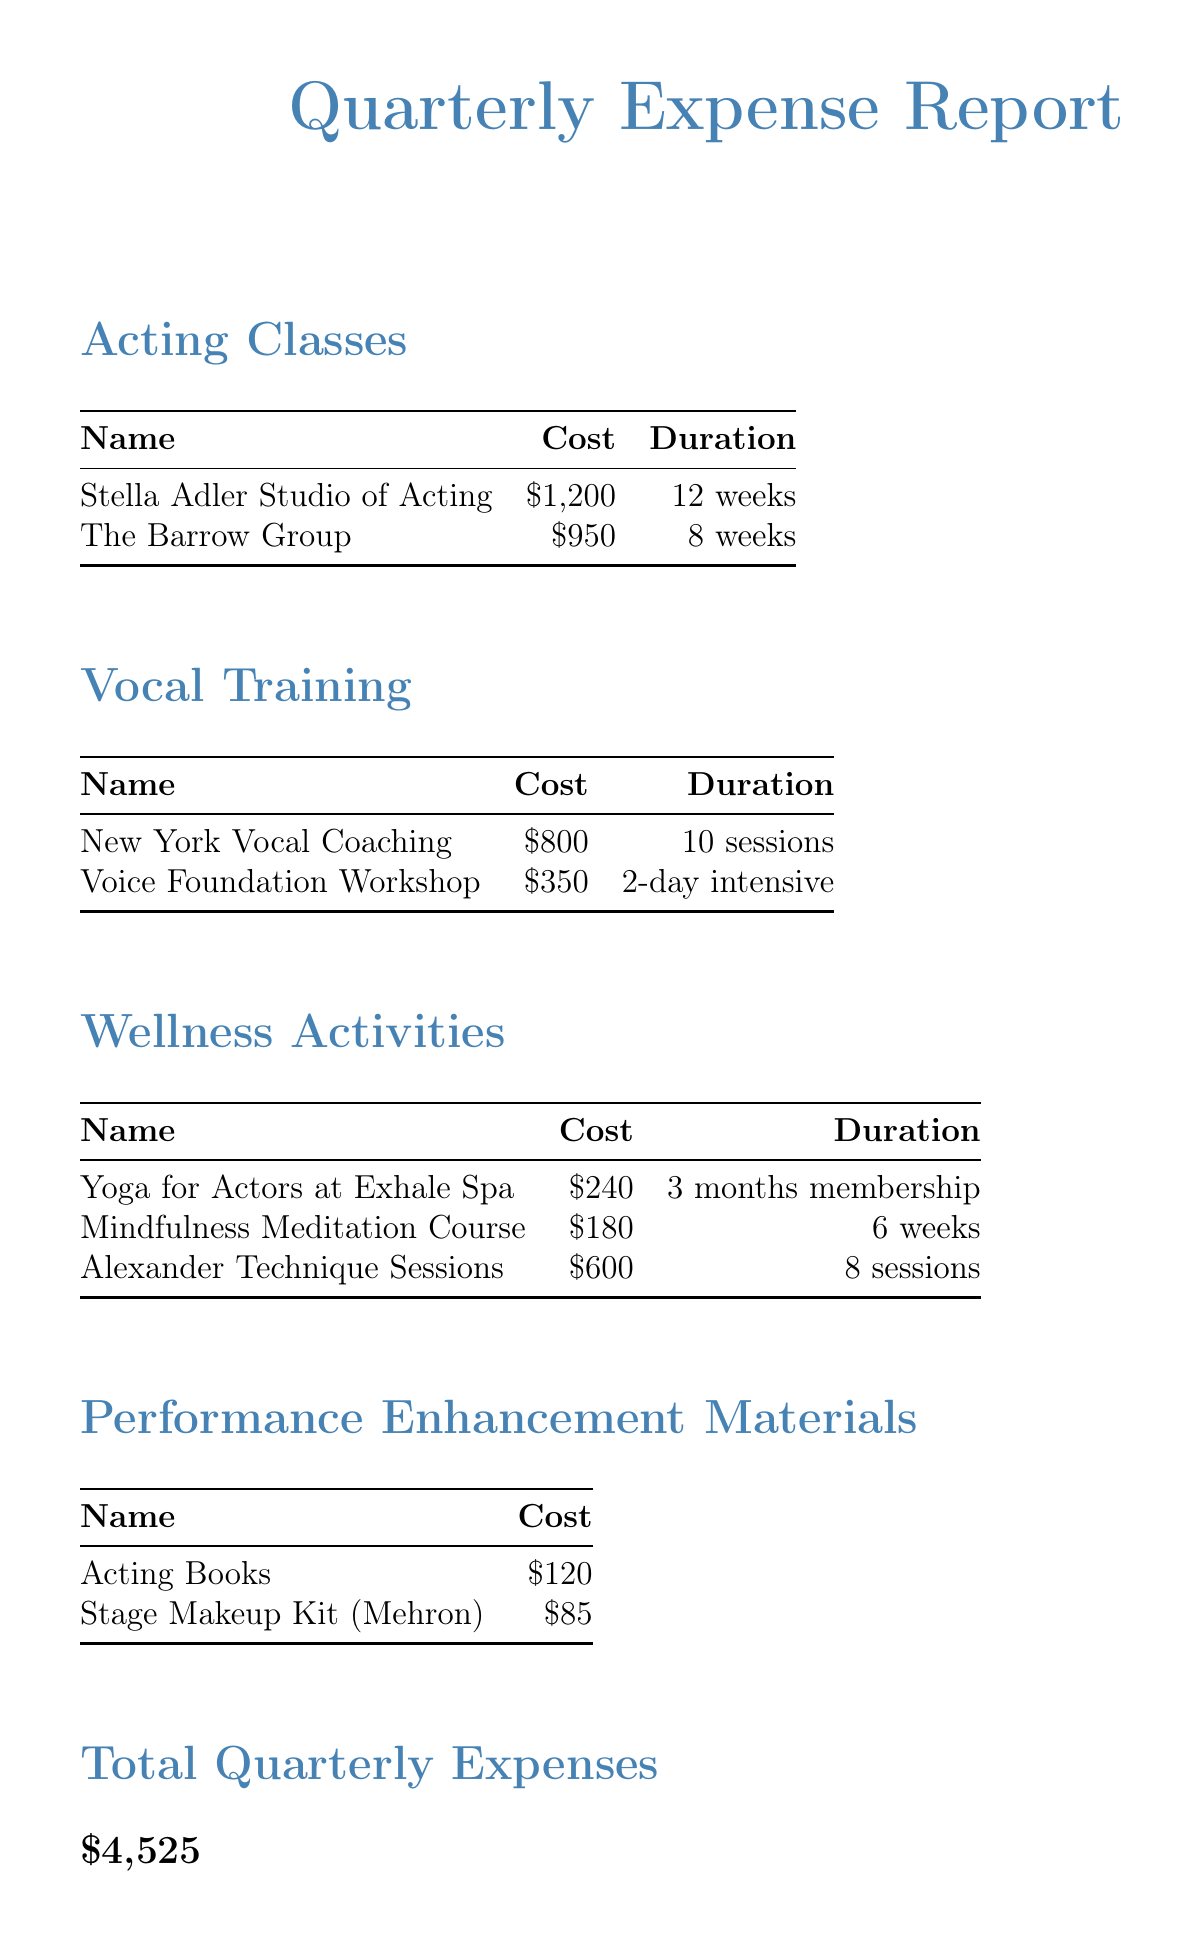what is the total quarterly expense? The total quarterly expense is provided as the final amount in the document under "Total Quarterly Expenses."
Answer: $4,525 how many weeks is the duration of the Stella Adler Studio of Acting? The duration of the Stella Adler Studio of Acting is mentioned in the table of acting classes.
Answer: 12 weeks what is the cost of the Voice Foundation Workshop? The Voice Foundation Workshop's cost is listed in the vocal training section of the document.
Answer: $350 how many sessions does New York Vocal Coaching provide? The duration of New York Vocal Coaching is indicated in the vocal training section stating the number of sessions.
Answer: 10 sessions which wellness activity costs $240? The wellness activity costing $240 is specified in the wellness activities section of the document.
Answer: Yoga for Actors at Exhale Spa what type of enhancement materials are included in the expenses? The document lists types of materials under a section dedicated to performance enhancement materials.
Answer: Acting Books, Stage Makeup Kit why is holistic wellness emphasized in the notes? The notes section states the purpose of investing in wellness activities, highlighting a significant focus on sustainability in the actor's career.
Answer: long-term career sustainability who is the brand of the Stage Makeup Kit? The brand of the Stage Makeup Kit is given in the list of performance enhancement materials, indicating the specific brand used.
Answer: Mehron how many weeks is the duration of the Mindfulness Meditation Course? The duration of the Mindfulness Meditation Course is mentioned in the table of wellness activities.
Answer: 6 weeks 